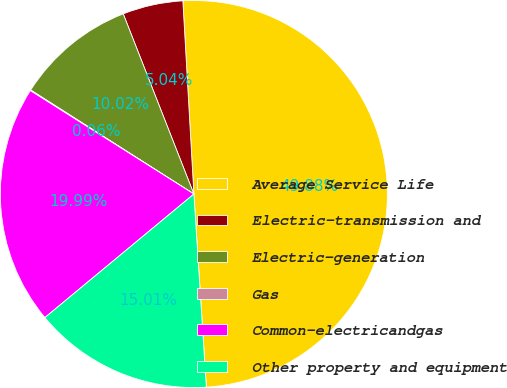<chart> <loc_0><loc_0><loc_500><loc_500><pie_chart><fcel>Average Service Life<fcel>Electric-transmission and<fcel>Electric-generation<fcel>Gas<fcel>Common-electricandgas<fcel>Other property and equipment<nl><fcel>49.88%<fcel>5.04%<fcel>10.02%<fcel>0.06%<fcel>19.99%<fcel>15.01%<nl></chart> 